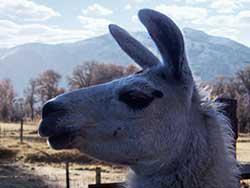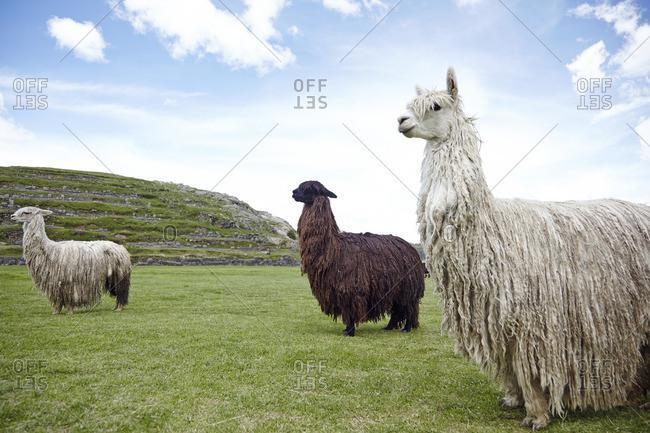The first image is the image on the left, the second image is the image on the right. For the images shown, is this caption "There are three llamas in the left image." true? Answer yes or no. No. The first image is the image on the left, the second image is the image on the right. Given the left and right images, does the statement "The left image contains exactly three shaggy llamas standing in front of a brown hill, with at least one llama looking directly at the camera." hold true? Answer yes or no. No. 